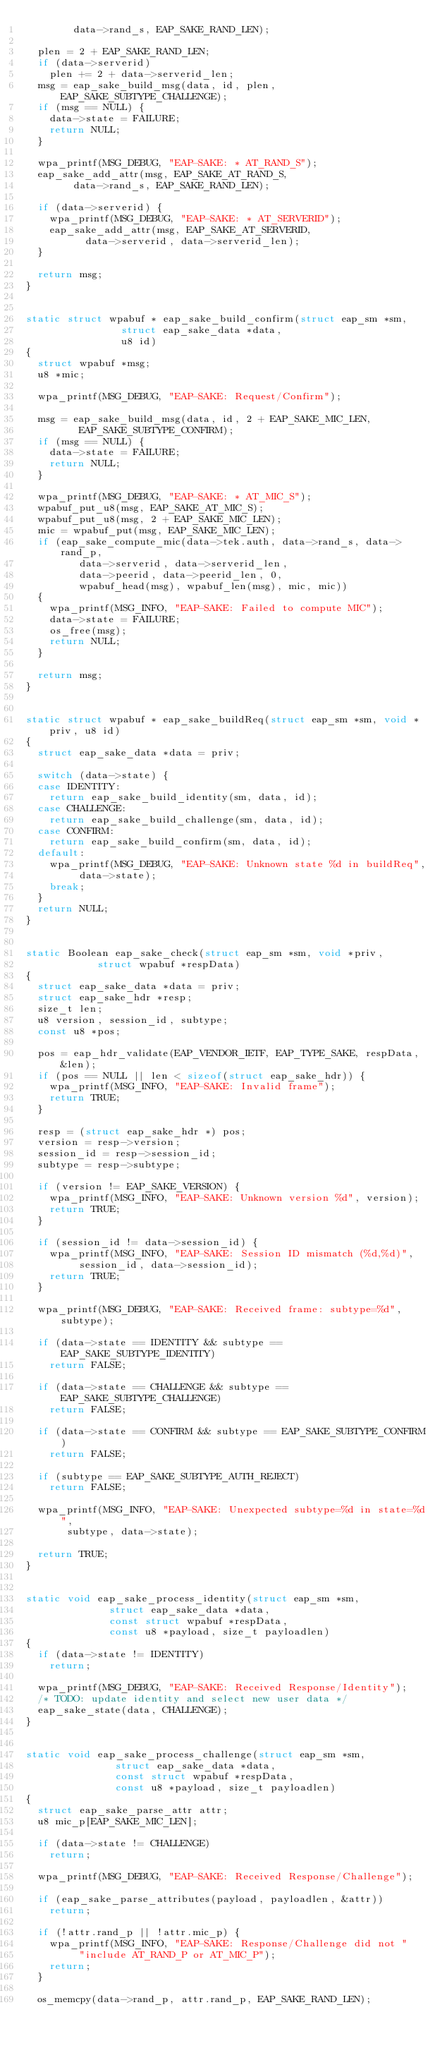Convert code to text. <code><loc_0><loc_0><loc_500><loc_500><_C_>		    data->rand_s, EAP_SAKE_RAND_LEN);

	plen = 2 + EAP_SAKE_RAND_LEN;
	if (data->serverid)
		plen += 2 + data->serverid_len;
	msg = eap_sake_build_msg(data, id, plen, EAP_SAKE_SUBTYPE_CHALLENGE);
	if (msg == NULL) {
		data->state = FAILURE;
		return NULL;
	}

	wpa_printf(MSG_DEBUG, "EAP-SAKE: * AT_RAND_S");
	eap_sake_add_attr(msg, EAP_SAKE_AT_RAND_S,
			  data->rand_s, EAP_SAKE_RAND_LEN);

	if (data->serverid) {
		wpa_printf(MSG_DEBUG, "EAP-SAKE: * AT_SERVERID");
		eap_sake_add_attr(msg, EAP_SAKE_AT_SERVERID,
				  data->serverid, data->serverid_len);
	}

	return msg;
}


static struct wpabuf * eap_sake_build_confirm(struct eap_sm *sm,
					      struct eap_sake_data *data,
					      u8 id)
{
	struct wpabuf *msg;
	u8 *mic;

	wpa_printf(MSG_DEBUG, "EAP-SAKE: Request/Confirm");

	msg = eap_sake_build_msg(data, id, 2 + EAP_SAKE_MIC_LEN,
				 EAP_SAKE_SUBTYPE_CONFIRM);
	if (msg == NULL) {
		data->state = FAILURE;
		return NULL;
	}

	wpa_printf(MSG_DEBUG, "EAP-SAKE: * AT_MIC_S");
	wpabuf_put_u8(msg, EAP_SAKE_AT_MIC_S);
	wpabuf_put_u8(msg, 2 + EAP_SAKE_MIC_LEN);
	mic = wpabuf_put(msg, EAP_SAKE_MIC_LEN);
	if (eap_sake_compute_mic(data->tek.auth, data->rand_s, data->rand_p,
				 data->serverid, data->serverid_len,
				 data->peerid, data->peerid_len, 0,
				 wpabuf_head(msg), wpabuf_len(msg), mic, mic))
	{
		wpa_printf(MSG_INFO, "EAP-SAKE: Failed to compute MIC");
		data->state = FAILURE;
		os_free(msg);
		return NULL;
	}

	return msg;
}


static struct wpabuf * eap_sake_buildReq(struct eap_sm *sm, void *priv, u8 id)
{
	struct eap_sake_data *data = priv;

	switch (data->state) {
	case IDENTITY:
		return eap_sake_build_identity(sm, data, id);
	case CHALLENGE:
		return eap_sake_build_challenge(sm, data, id);
	case CONFIRM:
		return eap_sake_build_confirm(sm, data, id);
	default:
		wpa_printf(MSG_DEBUG, "EAP-SAKE: Unknown state %d in buildReq",
			   data->state);
		break;
	}
	return NULL;
}


static Boolean eap_sake_check(struct eap_sm *sm, void *priv,
			      struct wpabuf *respData)
{
	struct eap_sake_data *data = priv;
	struct eap_sake_hdr *resp;
	size_t len;
	u8 version, session_id, subtype;
	const u8 *pos;

	pos = eap_hdr_validate(EAP_VENDOR_IETF, EAP_TYPE_SAKE, respData, &len);
	if (pos == NULL || len < sizeof(struct eap_sake_hdr)) {
		wpa_printf(MSG_INFO, "EAP-SAKE: Invalid frame");
		return TRUE;
	}

	resp = (struct eap_sake_hdr *) pos;
	version = resp->version;
	session_id = resp->session_id;
	subtype = resp->subtype;

	if (version != EAP_SAKE_VERSION) {
		wpa_printf(MSG_INFO, "EAP-SAKE: Unknown version %d", version);
		return TRUE;
	}

	if (session_id != data->session_id) {
		wpa_printf(MSG_INFO, "EAP-SAKE: Session ID mismatch (%d,%d)",
			   session_id, data->session_id);
		return TRUE;
	}

	wpa_printf(MSG_DEBUG, "EAP-SAKE: Received frame: subtype=%d", subtype);

	if (data->state == IDENTITY && subtype == EAP_SAKE_SUBTYPE_IDENTITY)
		return FALSE;

	if (data->state == CHALLENGE && subtype == EAP_SAKE_SUBTYPE_CHALLENGE)
		return FALSE;

	if (data->state == CONFIRM && subtype == EAP_SAKE_SUBTYPE_CONFIRM)
		return FALSE;

	if (subtype == EAP_SAKE_SUBTYPE_AUTH_REJECT)
		return FALSE;

	wpa_printf(MSG_INFO, "EAP-SAKE: Unexpected subtype=%d in state=%d",
		   subtype, data->state);

	return TRUE;
}


static void eap_sake_process_identity(struct eap_sm *sm,
				      struct eap_sake_data *data,
				      const struct wpabuf *respData,
				      const u8 *payload, size_t payloadlen)
{
	if (data->state != IDENTITY)
		return;

	wpa_printf(MSG_DEBUG, "EAP-SAKE: Received Response/Identity");
	/* TODO: update identity and select new user data */
	eap_sake_state(data, CHALLENGE);
}


static void eap_sake_process_challenge(struct eap_sm *sm,
				       struct eap_sake_data *data,
				       const struct wpabuf *respData,
				       const u8 *payload, size_t payloadlen)
{
	struct eap_sake_parse_attr attr;
	u8 mic_p[EAP_SAKE_MIC_LEN];

	if (data->state != CHALLENGE)
		return;

	wpa_printf(MSG_DEBUG, "EAP-SAKE: Received Response/Challenge");

	if (eap_sake_parse_attributes(payload, payloadlen, &attr))
		return;

	if (!attr.rand_p || !attr.mic_p) {
		wpa_printf(MSG_INFO, "EAP-SAKE: Response/Challenge did not "
			   "include AT_RAND_P or AT_MIC_P");
		return;
	}

	os_memcpy(data->rand_p, attr.rand_p, EAP_SAKE_RAND_LEN);
</code> 